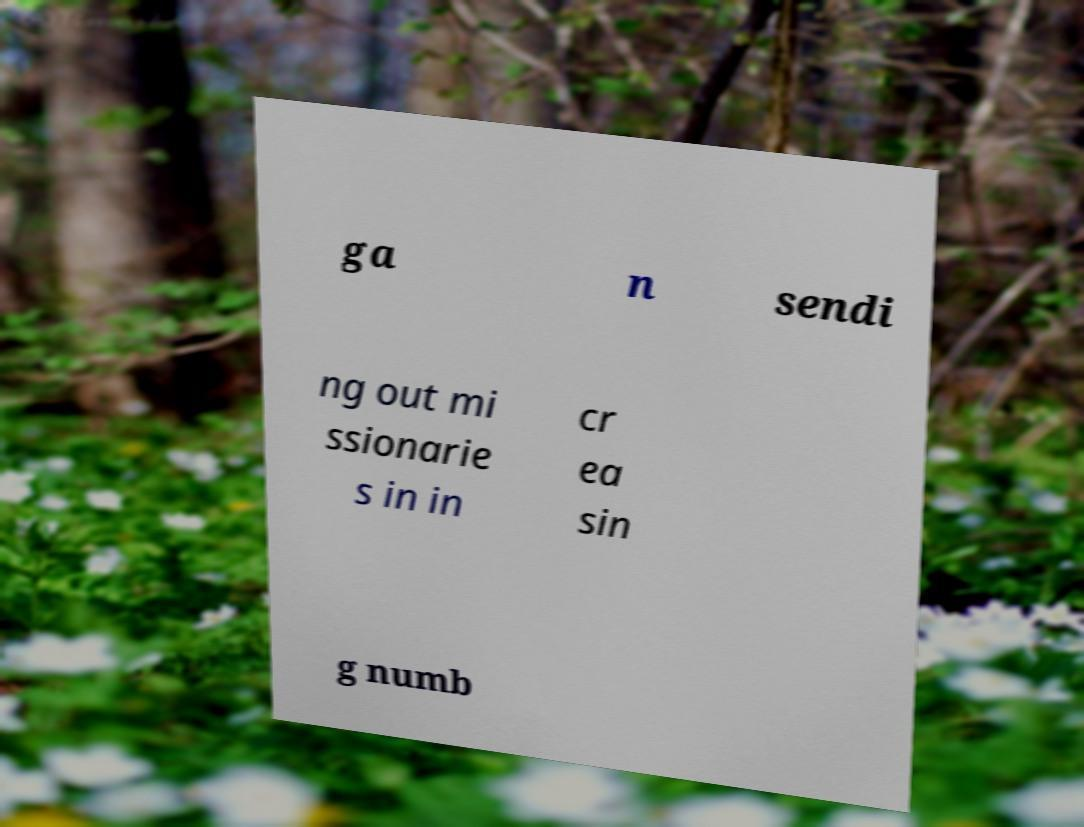Can you read and provide the text displayed in the image?This photo seems to have some interesting text. Can you extract and type it out for me? ga n sendi ng out mi ssionarie s in in cr ea sin g numb 